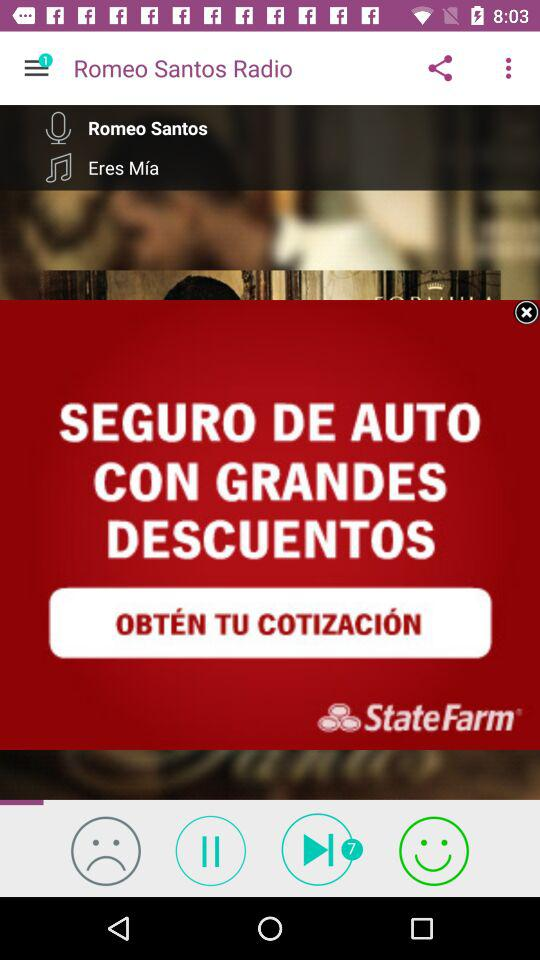What is the name of the application? The name of the application is "Romeo Santos Radio". 